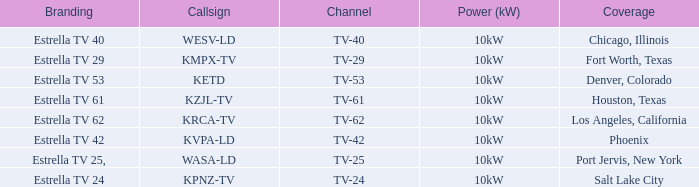What is the power capacity for channel tv-29? 10kW. 